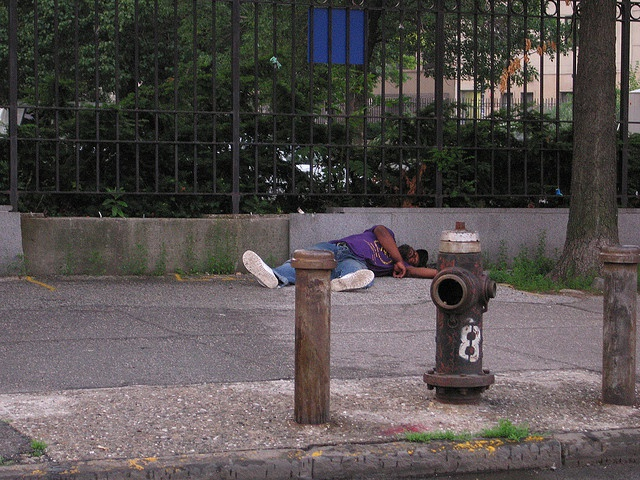Describe the objects in this image and their specific colors. I can see fire hydrant in black, gray, and darkgray tones and people in black, gray, and purple tones in this image. 